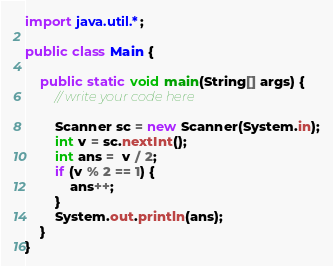<code> <loc_0><loc_0><loc_500><loc_500><_Java_>import java.util.*;

public class Main {

    public static void main(String[] args) {
        // write your code here

        Scanner sc = new Scanner(System.in);
        int v = sc.nextInt();
        int ans =  v / 2;
        if (v % 2 == 1) {
            ans++;
        }
        System.out.println(ans);
    }
}
</code> 